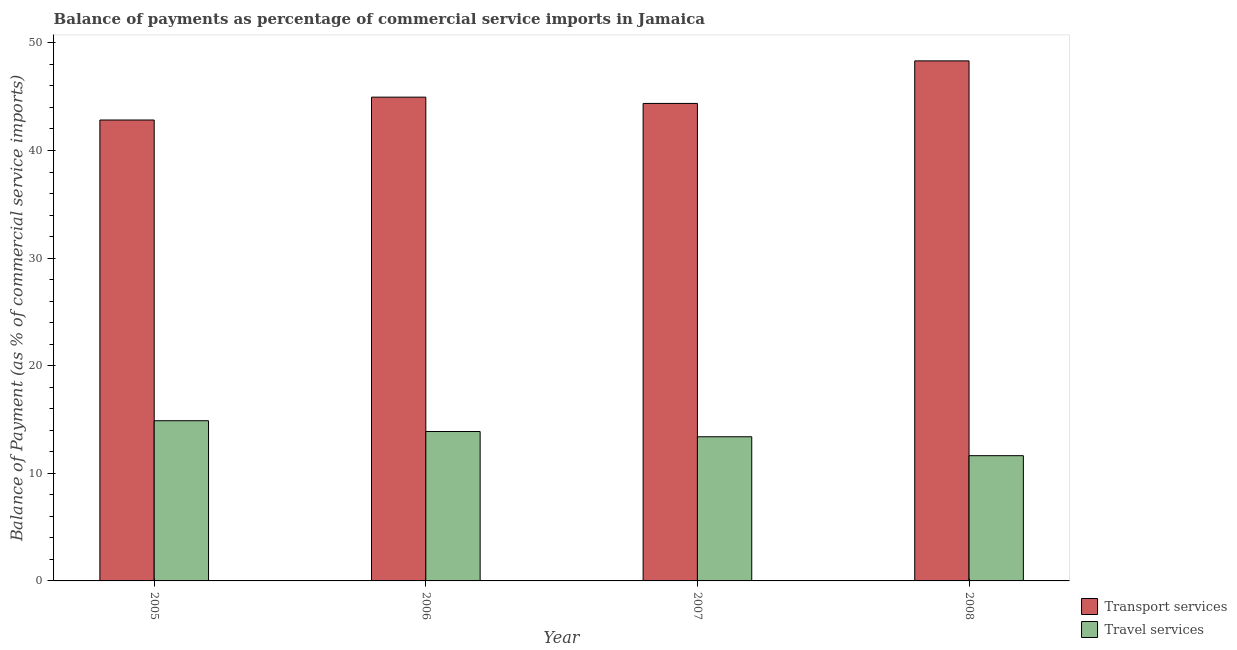How many different coloured bars are there?
Make the answer very short. 2. Are the number of bars per tick equal to the number of legend labels?
Your answer should be very brief. Yes. How many bars are there on the 4th tick from the right?
Offer a terse response. 2. What is the balance of payments of transport services in 2007?
Provide a succinct answer. 44.37. Across all years, what is the maximum balance of payments of transport services?
Make the answer very short. 48.33. Across all years, what is the minimum balance of payments of transport services?
Keep it short and to the point. 42.83. In which year was the balance of payments of transport services maximum?
Keep it short and to the point. 2008. What is the total balance of payments of transport services in the graph?
Your response must be concise. 180.49. What is the difference between the balance of payments of travel services in 2006 and that in 2007?
Ensure brevity in your answer.  0.49. What is the difference between the balance of payments of transport services in 2005 and the balance of payments of travel services in 2007?
Make the answer very short. -1.54. What is the average balance of payments of travel services per year?
Offer a terse response. 13.45. In the year 2006, what is the difference between the balance of payments of travel services and balance of payments of transport services?
Keep it short and to the point. 0. In how many years, is the balance of payments of transport services greater than 46 %?
Provide a short and direct response. 1. What is the ratio of the balance of payments of travel services in 2005 to that in 2008?
Provide a short and direct response. 1.28. Is the balance of payments of transport services in 2006 less than that in 2007?
Provide a succinct answer. No. What is the difference between the highest and the second highest balance of payments of transport services?
Keep it short and to the point. 3.37. What is the difference between the highest and the lowest balance of payments of transport services?
Your response must be concise. 5.49. Is the sum of the balance of payments of transport services in 2006 and 2007 greater than the maximum balance of payments of travel services across all years?
Your response must be concise. Yes. What does the 1st bar from the left in 2007 represents?
Offer a terse response. Transport services. What does the 2nd bar from the right in 2007 represents?
Keep it short and to the point. Transport services. Are all the bars in the graph horizontal?
Your answer should be very brief. No. How many years are there in the graph?
Offer a terse response. 4. Are the values on the major ticks of Y-axis written in scientific E-notation?
Offer a terse response. No. Does the graph contain any zero values?
Your answer should be very brief. No. Does the graph contain grids?
Offer a very short reply. No. How many legend labels are there?
Your answer should be compact. 2. How are the legend labels stacked?
Keep it short and to the point. Vertical. What is the title of the graph?
Your answer should be very brief. Balance of payments as percentage of commercial service imports in Jamaica. What is the label or title of the Y-axis?
Your response must be concise. Balance of Payment (as % of commercial service imports). What is the Balance of Payment (as % of commercial service imports) in Transport services in 2005?
Ensure brevity in your answer.  42.83. What is the Balance of Payment (as % of commercial service imports) in Travel services in 2005?
Your answer should be compact. 14.89. What is the Balance of Payment (as % of commercial service imports) of Transport services in 2006?
Make the answer very short. 44.96. What is the Balance of Payment (as % of commercial service imports) in Travel services in 2006?
Your answer should be very brief. 13.88. What is the Balance of Payment (as % of commercial service imports) in Transport services in 2007?
Offer a very short reply. 44.37. What is the Balance of Payment (as % of commercial service imports) of Travel services in 2007?
Make the answer very short. 13.4. What is the Balance of Payment (as % of commercial service imports) in Transport services in 2008?
Your answer should be very brief. 48.33. What is the Balance of Payment (as % of commercial service imports) in Travel services in 2008?
Ensure brevity in your answer.  11.64. Across all years, what is the maximum Balance of Payment (as % of commercial service imports) of Transport services?
Provide a succinct answer. 48.33. Across all years, what is the maximum Balance of Payment (as % of commercial service imports) in Travel services?
Your answer should be compact. 14.89. Across all years, what is the minimum Balance of Payment (as % of commercial service imports) of Transport services?
Your response must be concise. 42.83. Across all years, what is the minimum Balance of Payment (as % of commercial service imports) of Travel services?
Provide a succinct answer. 11.64. What is the total Balance of Payment (as % of commercial service imports) of Transport services in the graph?
Your answer should be very brief. 180.49. What is the total Balance of Payment (as % of commercial service imports) of Travel services in the graph?
Give a very brief answer. 53.81. What is the difference between the Balance of Payment (as % of commercial service imports) of Transport services in 2005 and that in 2006?
Offer a very short reply. -2.12. What is the difference between the Balance of Payment (as % of commercial service imports) in Travel services in 2005 and that in 2006?
Make the answer very short. 1. What is the difference between the Balance of Payment (as % of commercial service imports) of Transport services in 2005 and that in 2007?
Keep it short and to the point. -1.54. What is the difference between the Balance of Payment (as % of commercial service imports) in Travel services in 2005 and that in 2007?
Your answer should be very brief. 1.49. What is the difference between the Balance of Payment (as % of commercial service imports) in Transport services in 2005 and that in 2008?
Make the answer very short. -5.49. What is the difference between the Balance of Payment (as % of commercial service imports) in Travel services in 2005 and that in 2008?
Ensure brevity in your answer.  3.25. What is the difference between the Balance of Payment (as % of commercial service imports) of Transport services in 2006 and that in 2007?
Provide a short and direct response. 0.58. What is the difference between the Balance of Payment (as % of commercial service imports) in Travel services in 2006 and that in 2007?
Keep it short and to the point. 0.49. What is the difference between the Balance of Payment (as % of commercial service imports) of Transport services in 2006 and that in 2008?
Offer a terse response. -3.37. What is the difference between the Balance of Payment (as % of commercial service imports) of Travel services in 2006 and that in 2008?
Make the answer very short. 2.24. What is the difference between the Balance of Payment (as % of commercial service imports) of Transport services in 2007 and that in 2008?
Provide a succinct answer. -3.95. What is the difference between the Balance of Payment (as % of commercial service imports) of Travel services in 2007 and that in 2008?
Give a very brief answer. 1.76. What is the difference between the Balance of Payment (as % of commercial service imports) in Transport services in 2005 and the Balance of Payment (as % of commercial service imports) in Travel services in 2006?
Keep it short and to the point. 28.95. What is the difference between the Balance of Payment (as % of commercial service imports) in Transport services in 2005 and the Balance of Payment (as % of commercial service imports) in Travel services in 2007?
Your answer should be very brief. 29.44. What is the difference between the Balance of Payment (as % of commercial service imports) of Transport services in 2005 and the Balance of Payment (as % of commercial service imports) of Travel services in 2008?
Your response must be concise. 31.2. What is the difference between the Balance of Payment (as % of commercial service imports) of Transport services in 2006 and the Balance of Payment (as % of commercial service imports) of Travel services in 2007?
Ensure brevity in your answer.  31.56. What is the difference between the Balance of Payment (as % of commercial service imports) of Transport services in 2006 and the Balance of Payment (as % of commercial service imports) of Travel services in 2008?
Ensure brevity in your answer.  33.32. What is the difference between the Balance of Payment (as % of commercial service imports) in Transport services in 2007 and the Balance of Payment (as % of commercial service imports) in Travel services in 2008?
Offer a terse response. 32.73. What is the average Balance of Payment (as % of commercial service imports) of Transport services per year?
Make the answer very short. 45.12. What is the average Balance of Payment (as % of commercial service imports) of Travel services per year?
Your response must be concise. 13.45. In the year 2005, what is the difference between the Balance of Payment (as % of commercial service imports) in Transport services and Balance of Payment (as % of commercial service imports) in Travel services?
Ensure brevity in your answer.  27.95. In the year 2006, what is the difference between the Balance of Payment (as % of commercial service imports) in Transport services and Balance of Payment (as % of commercial service imports) in Travel services?
Provide a short and direct response. 31.07. In the year 2007, what is the difference between the Balance of Payment (as % of commercial service imports) of Transport services and Balance of Payment (as % of commercial service imports) of Travel services?
Keep it short and to the point. 30.98. In the year 2008, what is the difference between the Balance of Payment (as % of commercial service imports) of Transport services and Balance of Payment (as % of commercial service imports) of Travel services?
Keep it short and to the point. 36.69. What is the ratio of the Balance of Payment (as % of commercial service imports) in Transport services in 2005 to that in 2006?
Offer a terse response. 0.95. What is the ratio of the Balance of Payment (as % of commercial service imports) of Travel services in 2005 to that in 2006?
Offer a terse response. 1.07. What is the ratio of the Balance of Payment (as % of commercial service imports) of Transport services in 2005 to that in 2007?
Your answer should be compact. 0.97. What is the ratio of the Balance of Payment (as % of commercial service imports) in Travel services in 2005 to that in 2007?
Provide a succinct answer. 1.11. What is the ratio of the Balance of Payment (as % of commercial service imports) in Transport services in 2005 to that in 2008?
Offer a very short reply. 0.89. What is the ratio of the Balance of Payment (as % of commercial service imports) in Travel services in 2005 to that in 2008?
Your answer should be compact. 1.28. What is the ratio of the Balance of Payment (as % of commercial service imports) in Transport services in 2006 to that in 2007?
Your answer should be compact. 1.01. What is the ratio of the Balance of Payment (as % of commercial service imports) in Travel services in 2006 to that in 2007?
Your answer should be very brief. 1.04. What is the ratio of the Balance of Payment (as % of commercial service imports) in Transport services in 2006 to that in 2008?
Your answer should be very brief. 0.93. What is the ratio of the Balance of Payment (as % of commercial service imports) of Travel services in 2006 to that in 2008?
Provide a succinct answer. 1.19. What is the ratio of the Balance of Payment (as % of commercial service imports) in Transport services in 2007 to that in 2008?
Offer a terse response. 0.92. What is the ratio of the Balance of Payment (as % of commercial service imports) in Travel services in 2007 to that in 2008?
Offer a terse response. 1.15. What is the difference between the highest and the second highest Balance of Payment (as % of commercial service imports) in Transport services?
Your response must be concise. 3.37. What is the difference between the highest and the second highest Balance of Payment (as % of commercial service imports) in Travel services?
Offer a terse response. 1. What is the difference between the highest and the lowest Balance of Payment (as % of commercial service imports) of Transport services?
Offer a very short reply. 5.49. What is the difference between the highest and the lowest Balance of Payment (as % of commercial service imports) of Travel services?
Your answer should be compact. 3.25. 